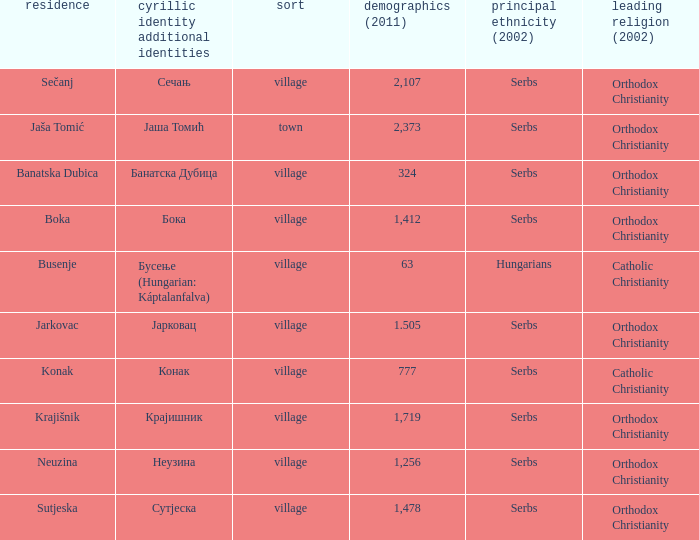What is the ethnic group is конак? Serbs. 